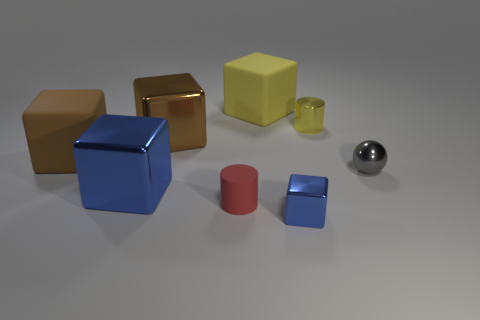What number of other objects are the same color as the tiny metallic cylinder?
Your answer should be very brief. 1. Is the shape of the tiny yellow shiny thing the same as the big yellow matte thing?
Your answer should be very brief. No. Does the small cylinder behind the metal ball have the same material as the large object that is right of the small red rubber thing?
Your response must be concise. No. How many objects are small objects that are to the left of the large yellow rubber cube or gray metallic balls that are right of the tiny shiny cylinder?
Your answer should be compact. 2. Is there anything else that has the same shape as the small gray metallic object?
Ensure brevity in your answer.  No. How many red rubber cylinders are there?
Offer a very short reply. 1. Are there any cylinders of the same size as the yellow block?
Your response must be concise. No. Does the tiny red thing have the same material as the tiny cylinder to the right of the tiny red matte thing?
Make the answer very short. No. There is a small cylinder in front of the small gray sphere; what material is it?
Your answer should be compact. Rubber. What size is the yellow cube?
Keep it short and to the point. Large. 